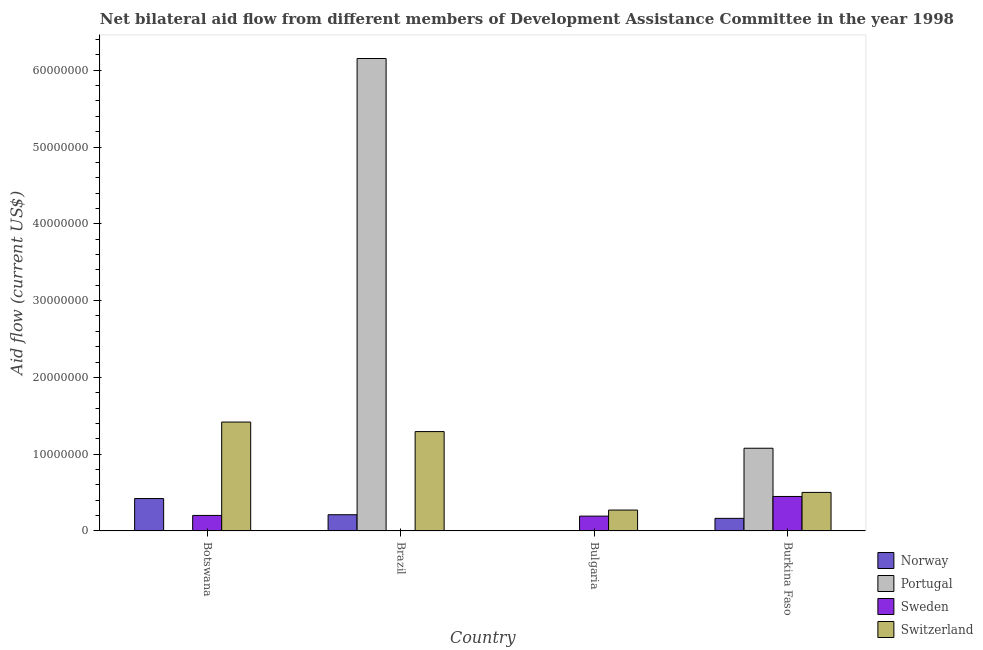How many different coloured bars are there?
Provide a succinct answer. 4. Are the number of bars per tick equal to the number of legend labels?
Your answer should be compact. Yes. Are the number of bars on each tick of the X-axis equal?
Your answer should be very brief. Yes. How many bars are there on the 3rd tick from the left?
Your response must be concise. 4. What is the label of the 2nd group of bars from the left?
Your answer should be very brief. Brazil. In how many cases, is the number of bars for a given country not equal to the number of legend labels?
Offer a terse response. 0. What is the amount of aid given by norway in Brazil?
Offer a very short reply. 2.11e+06. Across all countries, what is the maximum amount of aid given by norway?
Make the answer very short. 4.22e+06. Across all countries, what is the minimum amount of aid given by norway?
Offer a very short reply. 5.00e+04. In which country was the amount of aid given by sweden maximum?
Your response must be concise. Burkina Faso. In which country was the amount of aid given by sweden minimum?
Ensure brevity in your answer.  Brazil. What is the total amount of aid given by sweden in the graph?
Keep it short and to the point. 8.49e+06. What is the difference between the amount of aid given by portugal in Brazil and that in Bulgaria?
Ensure brevity in your answer.  6.15e+07. What is the difference between the amount of aid given by sweden in Bulgaria and the amount of aid given by portugal in Botswana?
Offer a terse response. 1.91e+06. What is the average amount of aid given by norway per country?
Keep it short and to the point. 2.00e+06. What is the difference between the amount of aid given by portugal and amount of aid given by sweden in Burkina Faso?
Give a very brief answer. 6.28e+06. What is the ratio of the amount of aid given by sweden in Brazil to that in Bulgaria?
Ensure brevity in your answer.  0.03. Is the difference between the amount of aid given by portugal in Bulgaria and Burkina Faso greater than the difference between the amount of aid given by sweden in Bulgaria and Burkina Faso?
Provide a short and direct response. No. What is the difference between the highest and the second highest amount of aid given by switzerland?
Make the answer very short. 1.24e+06. What is the difference between the highest and the lowest amount of aid given by switzerland?
Your response must be concise. 1.15e+07. In how many countries, is the amount of aid given by norway greater than the average amount of aid given by norway taken over all countries?
Make the answer very short. 2. Is it the case that in every country, the sum of the amount of aid given by sweden and amount of aid given by portugal is greater than the sum of amount of aid given by norway and amount of aid given by switzerland?
Keep it short and to the point. No. What does the 4th bar from the left in Bulgaria represents?
Keep it short and to the point. Switzerland. Are all the bars in the graph horizontal?
Give a very brief answer. No. What is the difference between two consecutive major ticks on the Y-axis?
Give a very brief answer. 1.00e+07. Does the graph contain grids?
Keep it short and to the point. No. Where does the legend appear in the graph?
Keep it short and to the point. Bottom right. How many legend labels are there?
Your answer should be compact. 4. How are the legend labels stacked?
Ensure brevity in your answer.  Vertical. What is the title of the graph?
Offer a terse response. Net bilateral aid flow from different members of Development Assistance Committee in the year 1998. Does "Agricultural land" appear as one of the legend labels in the graph?
Your answer should be compact. No. What is the label or title of the X-axis?
Your answer should be compact. Country. What is the label or title of the Y-axis?
Ensure brevity in your answer.  Aid flow (current US$). What is the Aid flow (current US$) of Norway in Botswana?
Provide a succinct answer. 4.22e+06. What is the Aid flow (current US$) in Sweden in Botswana?
Provide a short and direct response. 2.02e+06. What is the Aid flow (current US$) of Switzerland in Botswana?
Ensure brevity in your answer.  1.42e+07. What is the Aid flow (current US$) of Norway in Brazil?
Offer a very short reply. 2.11e+06. What is the Aid flow (current US$) of Portugal in Brazil?
Your answer should be very brief. 6.15e+07. What is the Aid flow (current US$) of Switzerland in Brazil?
Offer a very short reply. 1.29e+07. What is the Aid flow (current US$) of Portugal in Bulgaria?
Your answer should be very brief. 10000. What is the Aid flow (current US$) in Sweden in Bulgaria?
Your answer should be compact. 1.93e+06. What is the Aid flow (current US$) of Switzerland in Bulgaria?
Offer a terse response. 2.72e+06. What is the Aid flow (current US$) of Norway in Burkina Faso?
Keep it short and to the point. 1.64e+06. What is the Aid flow (current US$) of Portugal in Burkina Faso?
Your response must be concise. 1.08e+07. What is the Aid flow (current US$) in Sweden in Burkina Faso?
Provide a short and direct response. 4.49e+06. What is the Aid flow (current US$) in Switzerland in Burkina Faso?
Offer a very short reply. 5.02e+06. Across all countries, what is the maximum Aid flow (current US$) of Norway?
Keep it short and to the point. 4.22e+06. Across all countries, what is the maximum Aid flow (current US$) of Portugal?
Provide a succinct answer. 6.15e+07. Across all countries, what is the maximum Aid flow (current US$) of Sweden?
Provide a succinct answer. 4.49e+06. Across all countries, what is the maximum Aid flow (current US$) of Switzerland?
Your response must be concise. 1.42e+07. Across all countries, what is the minimum Aid flow (current US$) of Sweden?
Provide a short and direct response. 5.00e+04. Across all countries, what is the minimum Aid flow (current US$) in Switzerland?
Your answer should be compact. 2.72e+06. What is the total Aid flow (current US$) of Norway in the graph?
Your response must be concise. 8.02e+06. What is the total Aid flow (current US$) of Portugal in the graph?
Your response must be concise. 7.23e+07. What is the total Aid flow (current US$) in Sweden in the graph?
Offer a very short reply. 8.49e+06. What is the total Aid flow (current US$) of Switzerland in the graph?
Offer a very short reply. 3.49e+07. What is the difference between the Aid flow (current US$) of Norway in Botswana and that in Brazil?
Make the answer very short. 2.11e+06. What is the difference between the Aid flow (current US$) in Portugal in Botswana and that in Brazil?
Your answer should be very brief. -6.15e+07. What is the difference between the Aid flow (current US$) of Sweden in Botswana and that in Brazil?
Offer a terse response. 1.97e+06. What is the difference between the Aid flow (current US$) in Switzerland in Botswana and that in Brazil?
Give a very brief answer. 1.24e+06. What is the difference between the Aid flow (current US$) in Norway in Botswana and that in Bulgaria?
Give a very brief answer. 4.17e+06. What is the difference between the Aid flow (current US$) of Switzerland in Botswana and that in Bulgaria?
Keep it short and to the point. 1.15e+07. What is the difference between the Aid flow (current US$) of Norway in Botswana and that in Burkina Faso?
Your response must be concise. 2.58e+06. What is the difference between the Aid flow (current US$) of Portugal in Botswana and that in Burkina Faso?
Give a very brief answer. -1.08e+07. What is the difference between the Aid flow (current US$) of Sweden in Botswana and that in Burkina Faso?
Ensure brevity in your answer.  -2.47e+06. What is the difference between the Aid flow (current US$) in Switzerland in Botswana and that in Burkina Faso?
Make the answer very short. 9.16e+06. What is the difference between the Aid flow (current US$) in Norway in Brazil and that in Bulgaria?
Keep it short and to the point. 2.06e+06. What is the difference between the Aid flow (current US$) of Portugal in Brazil and that in Bulgaria?
Offer a very short reply. 6.15e+07. What is the difference between the Aid flow (current US$) of Sweden in Brazil and that in Bulgaria?
Offer a terse response. -1.88e+06. What is the difference between the Aid flow (current US$) in Switzerland in Brazil and that in Bulgaria?
Your answer should be compact. 1.02e+07. What is the difference between the Aid flow (current US$) of Portugal in Brazil and that in Burkina Faso?
Your response must be concise. 5.08e+07. What is the difference between the Aid flow (current US$) in Sweden in Brazil and that in Burkina Faso?
Keep it short and to the point. -4.44e+06. What is the difference between the Aid flow (current US$) of Switzerland in Brazil and that in Burkina Faso?
Provide a succinct answer. 7.92e+06. What is the difference between the Aid flow (current US$) in Norway in Bulgaria and that in Burkina Faso?
Your response must be concise. -1.59e+06. What is the difference between the Aid flow (current US$) in Portugal in Bulgaria and that in Burkina Faso?
Provide a succinct answer. -1.08e+07. What is the difference between the Aid flow (current US$) of Sweden in Bulgaria and that in Burkina Faso?
Your answer should be very brief. -2.56e+06. What is the difference between the Aid flow (current US$) in Switzerland in Bulgaria and that in Burkina Faso?
Give a very brief answer. -2.30e+06. What is the difference between the Aid flow (current US$) in Norway in Botswana and the Aid flow (current US$) in Portugal in Brazil?
Make the answer very short. -5.73e+07. What is the difference between the Aid flow (current US$) of Norway in Botswana and the Aid flow (current US$) of Sweden in Brazil?
Your answer should be compact. 4.17e+06. What is the difference between the Aid flow (current US$) in Norway in Botswana and the Aid flow (current US$) in Switzerland in Brazil?
Ensure brevity in your answer.  -8.72e+06. What is the difference between the Aid flow (current US$) of Portugal in Botswana and the Aid flow (current US$) of Sweden in Brazil?
Offer a very short reply. -3.00e+04. What is the difference between the Aid flow (current US$) of Portugal in Botswana and the Aid flow (current US$) of Switzerland in Brazil?
Offer a terse response. -1.29e+07. What is the difference between the Aid flow (current US$) in Sweden in Botswana and the Aid flow (current US$) in Switzerland in Brazil?
Your response must be concise. -1.09e+07. What is the difference between the Aid flow (current US$) of Norway in Botswana and the Aid flow (current US$) of Portugal in Bulgaria?
Give a very brief answer. 4.21e+06. What is the difference between the Aid flow (current US$) of Norway in Botswana and the Aid flow (current US$) of Sweden in Bulgaria?
Give a very brief answer. 2.29e+06. What is the difference between the Aid flow (current US$) in Norway in Botswana and the Aid flow (current US$) in Switzerland in Bulgaria?
Keep it short and to the point. 1.50e+06. What is the difference between the Aid flow (current US$) of Portugal in Botswana and the Aid flow (current US$) of Sweden in Bulgaria?
Offer a terse response. -1.91e+06. What is the difference between the Aid flow (current US$) in Portugal in Botswana and the Aid flow (current US$) in Switzerland in Bulgaria?
Give a very brief answer. -2.70e+06. What is the difference between the Aid flow (current US$) of Sweden in Botswana and the Aid flow (current US$) of Switzerland in Bulgaria?
Offer a terse response. -7.00e+05. What is the difference between the Aid flow (current US$) of Norway in Botswana and the Aid flow (current US$) of Portugal in Burkina Faso?
Offer a very short reply. -6.55e+06. What is the difference between the Aid flow (current US$) in Norway in Botswana and the Aid flow (current US$) in Switzerland in Burkina Faso?
Provide a short and direct response. -8.00e+05. What is the difference between the Aid flow (current US$) in Portugal in Botswana and the Aid flow (current US$) in Sweden in Burkina Faso?
Provide a succinct answer. -4.47e+06. What is the difference between the Aid flow (current US$) of Portugal in Botswana and the Aid flow (current US$) of Switzerland in Burkina Faso?
Give a very brief answer. -5.00e+06. What is the difference between the Aid flow (current US$) in Norway in Brazil and the Aid flow (current US$) in Portugal in Bulgaria?
Your response must be concise. 2.10e+06. What is the difference between the Aid flow (current US$) in Norway in Brazil and the Aid flow (current US$) in Switzerland in Bulgaria?
Offer a terse response. -6.10e+05. What is the difference between the Aid flow (current US$) in Portugal in Brazil and the Aid flow (current US$) in Sweden in Bulgaria?
Keep it short and to the point. 5.96e+07. What is the difference between the Aid flow (current US$) of Portugal in Brazil and the Aid flow (current US$) of Switzerland in Bulgaria?
Keep it short and to the point. 5.88e+07. What is the difference between the Aid flow (current US$) in Sweden in Brazil and the Aid flow (current US$) in Switzerland in Bulgaria?
Ensure brevity in your answer.  -2.67e+06. What is the difference between the Aid flow (current US$) of Norway in Brazil and the Aid flow (current US$) of Portugal in Burkina Faso?
Provide a short and direct response. -8.66e+06. What is the difference between the Aid flow (current US$) in Norway in Brazil and the Aid flow (current US$) in Sweden in Burkina Faso?
Ensure brevity in your answer.  -2.38e+06. What is the difference between the Aid flow (current US$) in Norway in Brazil and the Aid flow (current US$) in Switzerland in Burkina Faso?
Offer a terse response. -2.91e+06. What is the difference between the Aid flow (current US$) of Portugal in Brazil and the Aid flow (current US$) of Sweden in Burkina Faso?
Your response must be concise. 5.70e+07. What is the difference between the Aid flow (current US$) in Portugal in Brazil and the Aid flow (current US$) in Switzerland in Burkina Faso?
Your answer should be compact. 5.65e+07. What is the difference between the Aid flow (current US$) in Sweden in Brazil and the Aid flow (current US$) in Switzerland in Burkina Faso?
Keep it short and to the point. -4.97e+06. What is the difference between the Aid flow (current US$) of Norway in Bulgaria and the Aid flow (current US$) of Portugal in Burkina Faso?
Your response must be concise. -1.07e+07. What is the difference between the Aid flow (current US$) of Norway in Bulgaria and the Aid flow (current US$) of Sweden in Burkina Faso?
Your answer should be very brief. -4.44e+06. What is the difference between the Aid flow (current US$) in Norway in Bulgaria and the Aid flow (current US$) in Switzerland in Burkina Faso?
Ensure brevity in your answer.  -4.97e+06. What is the difference between the Aid flow (current US$) in Portugal in Bulgaria and the Aid flow (current US$) in Sweden in Burkina Faso?
Your response must be concise. -4.48e+06. What is the difference between the Aid flow (current US$) of Portugal in Bulgaria and the Aid flow (current US$) of Switzerland in Burkina Faso?
Your answer should be compact. -5.01e+06. What is the difference between the Aid flow (current US$) in Sweden in Bulgaria and the Aid flow (current US$) in Switzerland in Burkina Faso?
Provide a short and direct response. -3.09e+06. What is the average Aid flow (current US$) in Norway per country?
Offer a very short reply. 2.00e+06. What is the average Aid flow (current US$) of Portugal per country?
Keep it short and to the point. 1.81e+07. What is the average Aid flow (current US$) of Sweden per country?
Ensure brevity in your answer.  2.12e+06. What is the average Aid flow (current US$) in Switzerland per country?
Your response must be concise. 8.72e+06. What is the difference between the Aid flow (current US$) in Norway and Aid flow (current US$) in Portugal in Botswana?
Your answer should be very brief. 4.20e+06. What is the difference between the Aid flow (current US$) in Norway and Aid flow (current US$) in Sweden in Botswana?
Make the answer very short. 2.20e+06. What is the difference between the Aid flow (current US$) in Norway and Aid flow (current US$) in Switzerland in Botswana?
Your answer should be very brief. -9.96e+06. What is the difference between the Aid flow (current US$) of Portugal and Aid flow (current US$) of Switzerland in Botswana?
Offer a terse response. -1.42e+07. What is the difference between the Aid flow (current US$) of Sweden and Aid flow (current US$) of Switzerland in Botswana?
Provide a short and direct response. -1.22e+07. What is the difference between the Aid flow (current US$) of Norway and Aid flow (current US$) of Portugal in Brazil?
Make the answer very short. -5.94e+07. What is the difference between the Aid flow (current US$) in Norway and Aid flow (current US$) in Sweden in Brazil?
Offer a terse response. 2.06e+06. What is the difference between the Aid flow (current US$) of Norway and Aid flow (current US$) of Switzerland in Brazil?
Make the answer very short. -1.08e+07. What is the difference between the Aid flow (current US$) of Portugal and Aid flow (current US$) of Sweden in Brazil?
Keep it short and to the point. 6.15e+07. What is the difference between the Aid flow (current US$) of Portugal and Aid flow (current US$) of Switzerland in Brazil?
Your answer should be compact. 4.86e+07. What is the difference between the Aid flow (current US$) in Sweden and Aid flow (current US$) in Switzerland in Brazil?
Provide a succinct answer. -1.29e+07. What is the difference between the Aid flow (current US$) in Norway and Aid flow (current US$) in Portugal in Bulgaria?
Keep it short and to the point. 4.00e+04. What is the difference between the Aid flow (current US$) in Norway and Aid flow (current US$) in Sweden in Bulgaria?
Your answer should be compact. -1.88e+06. What is the difference between the Aid flow (current US$) in Norway and Aid flow (current US$) in Switzerland in Bulgaria?
Provide a short and direct response. -2.67e+06. What is the difference between the Aid flow (current US$) of Portugal and Aid flow (current US$) of Sweden in Bulgaria?
Provide a succinct answer. -1.92e+06. What is the difference between the Aid flow (current US$) of Portugal and Aid flow (current US$) of Switzerland in Bulgaria?
Your answer should be very brief. -2.71e+06. What is the difference between the Aid flow (current US$) of Sweden and Aid flow (current US$) of Switzerland in Bulgaria?
Offer a terse response. -7.90e+05. What is the difference between the Aid flow (current US$) in Norway and Aid flow (current US$) in Portugal in Burkina Faso?
Offer a terse response. -9.13e+06. What is the difference between the Aid flow (current US$) of Norway and Aid flow (current US$) of Sweden in Burkina Faso?
Ensure brevity in your answer.  -2.85e+06. What is the difference between the Aid flow (current US$) of Norway and Aid flow (current US$) of Switzerland in Burkina Faso?
Your response must be concise. -3.38e+06. What is the difference between the Aid flow (current US$) in Portugal and Aid flow (current US$) in Sweden in Burkina Faso?
Provide a succinct answer. 6.28e+06. What is the difference between the Aid flow (current US$) in Portugal and Aid flow (current US$) in Switzerland in Burkina Faso?
Provide a succinct answer. 5.75e+06. What is the difference between the Aid flow (current US$) in Sweden and Aid flow (current US$) in Switzerland in Burkina Faso?
Ensure brevity in your answer.  -5.30e+05. What is the ratio of the Aid flow (current US$) of Norway in Botswana to that in Brazil?
Give a very brief answer. 2. What is the ratio of the Aid flow (current US$) of Portugal in Botswana to that in Brazil?
Your answer should be very brief. 0. What is the ratio of the Aid flow (current US$) in Sweden in Botswana to that in Brazil?
Offer a terse response. 40.4. What is the ratio of the Aid flow (current US$) of Switzerland in Botswana to that in Brazil?
Make the answer very short. 1.1. What is the ratio of the Aid flow (current US$) of Norway in Botswana to that in Bulgaria?
Keep it short and to the point. 84.4. What is the ratio of the Aid flow (current US$) of Portugal in Botswana to that in Bulgaria?
Offer a terse response. 2. What is the ratio of the Aid flow (current US$) in Sweden in Botswana to that in Bulgaria?
Offer a terse response. 1.05. What is the ratio of the Aid flow (current US$) in Switzerland in Botswana to that in Bulgaria?
Your response must be concise. 5.21. What is the ratio of the Aid flow (current US$) of Norway in Botswana to that in Burkina Faso?
Ensure brevity in your answer.  2.57. What is the ratio of the Aid flow (current US$) of Portugal in Botswana to that in Burkina Faso?
Offer a very short reply. 0. What is the ratio of the Aid flow (current US$) in Sweden in Botswana to that in Burkina Faso?
Your response must be concise. 0.45. What is the ratio of the Aid flow (current US$) of Switzerland in Botswana to that in Burkina Faso?
Provide a succinct answer. 2.82. What is the ratio of the Aid flow (current US$) in Norway in Brazil to that in Bulgaria?
Provide a succinct answer. 42.2. What is the ratio of the Aid flow (current US$) in Portugal in Brazil to that in Bulgaria?
Your response must be concise. 6153. What is the ratio of the Aid flow (current US$) of Sweden in Brazil to that in Bulgaria?
Give a very brief answer. 0.03. What is the ratio of the Aid flow (current US$) in Switzerland in Brazil to that in Bulgaria?
Provide a succinct answer. 4.76. What is the ratio of the Aid flow (current US$) of Norway in Brazil to that in Burkina Faso?
Ensure brevity in your answer.  1.29. What is the ratio of the Aid flow (current US$) in Portugal in Brazil to that in Burkina Faso?
Your response must be concise. 5.71. What is the ratio of the Aid flow (current US$) of Sweden in Brazil to that in Burkina Faso?
Your answer should be compact. 0.01. What is the ratio of the Aid flow (current US$) of Switzerland in Brazil to that in Burkina Faso?
Your response must be concise. 2.58. What is the ratio of the Aid flow (current US$) of Norway in Bulgaria to that in Burkina Faso?
Ensure brevity in your answer.  0.03. What is the ratio of the Aid flow (current US$) of Portugal in Bulgaria to that in Burkina Faso?
Your answer should be very brief. 0. What is the ratio of the Aid flow (current US$) of Sweden in Bulgaria to that in Burkina Faso?
Ensure brevity in your answer.  0.43. What is the ratio of the Aid flow (current US$) of Switzerland in Bulgaria to that in Burkina Faso?
Your response must be concise. 0.54. What is the difference between the highest and the second highest Aid flow (current US$) of Norway?
Provide a succinct answer. 2.11e+06. What is the difference between the highest and the second highest Aid flow (current US$) of Portugal?
Provide a succinct answer. 5.08e+07. What is the difference between the highest and the second highest Aid flow (current US$) of Sweden?
Ensure brevity in your answer.  2.47e+06. What is the difference between the highest and the second highest Aid flow (current US$) in Switzerland?
Ensure brevity in your answer.  1.24e+06. What is the difference between the highest and the lowest Aid flow (current US$) of Norway?
Your answer should be very brief. 4.17e+06. What is the difference between the highest and the lowest Aid flow (current US$) in Portugal?
Provide a succinct answer. 6.15e+07. What is the difference between the highest and the lowest Aid flow (current US$) of Sweden?
Provide a short and direct response. 4.44e+06. What is the difference between the highest and the lowest Aid flow (current US$) in Switzerland?
Your response must be concise. 1.15e+07. 